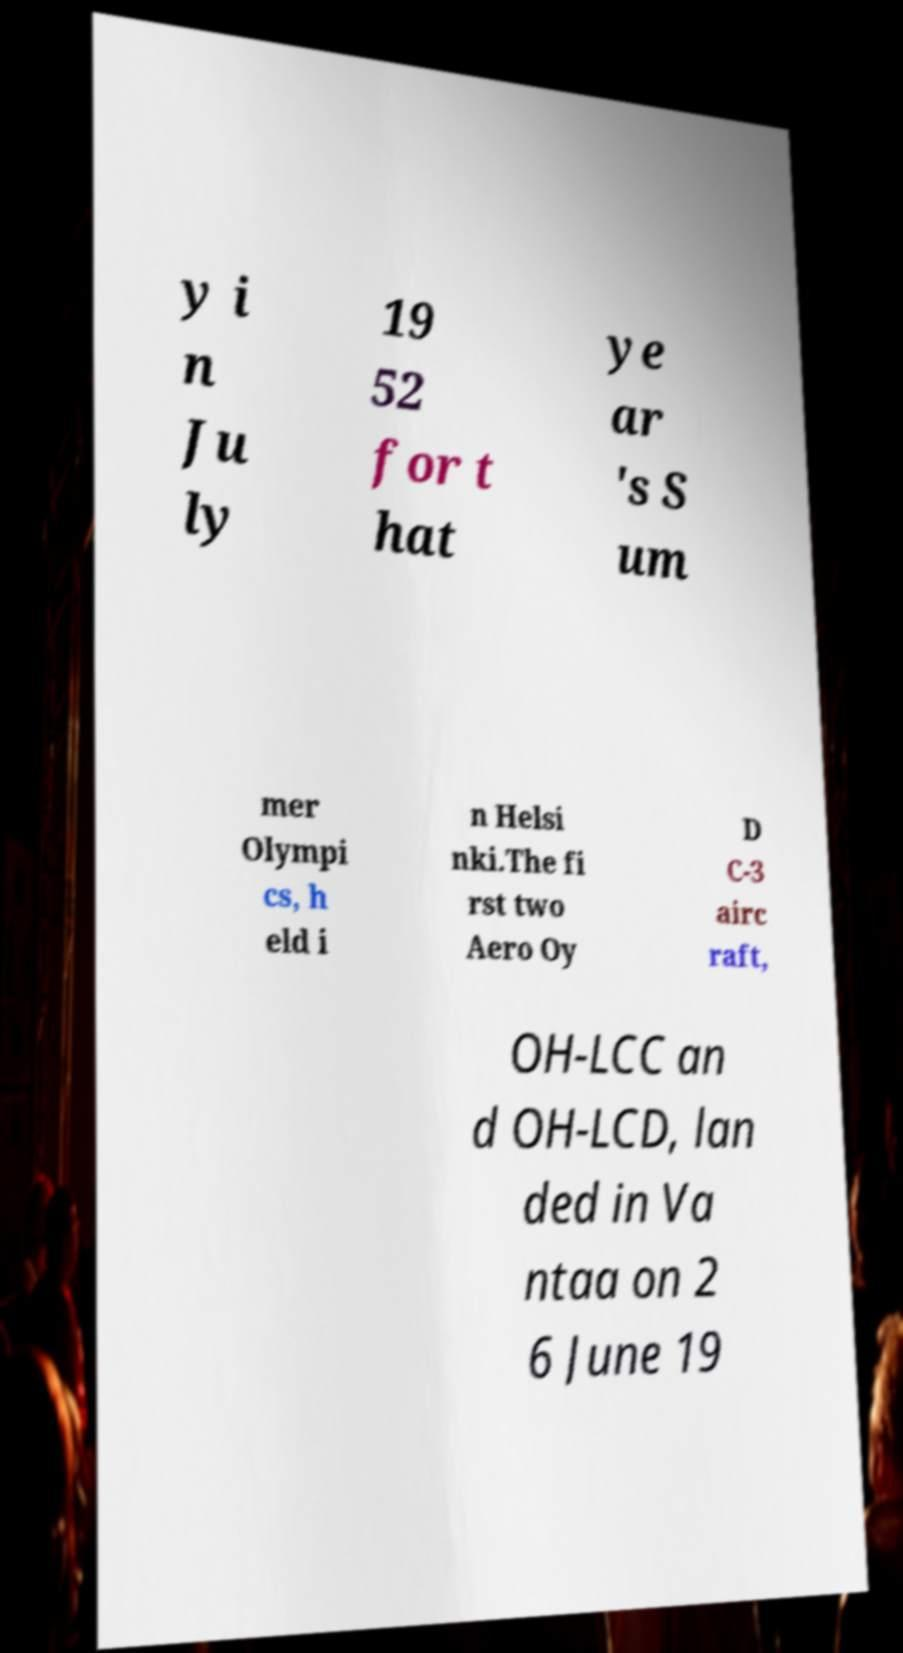Can you accurately transcribe the text from the provided image for me? y i n Ju ly 19 52 for t hat ye ar 's S um mer Olympi cs, h eld i n Helsi nki.The fi rst two Aero Oy D C-3 airc raft, OH-LCC an d OH-LCD, lan ded in Va ntaa on 2 6 June 19 